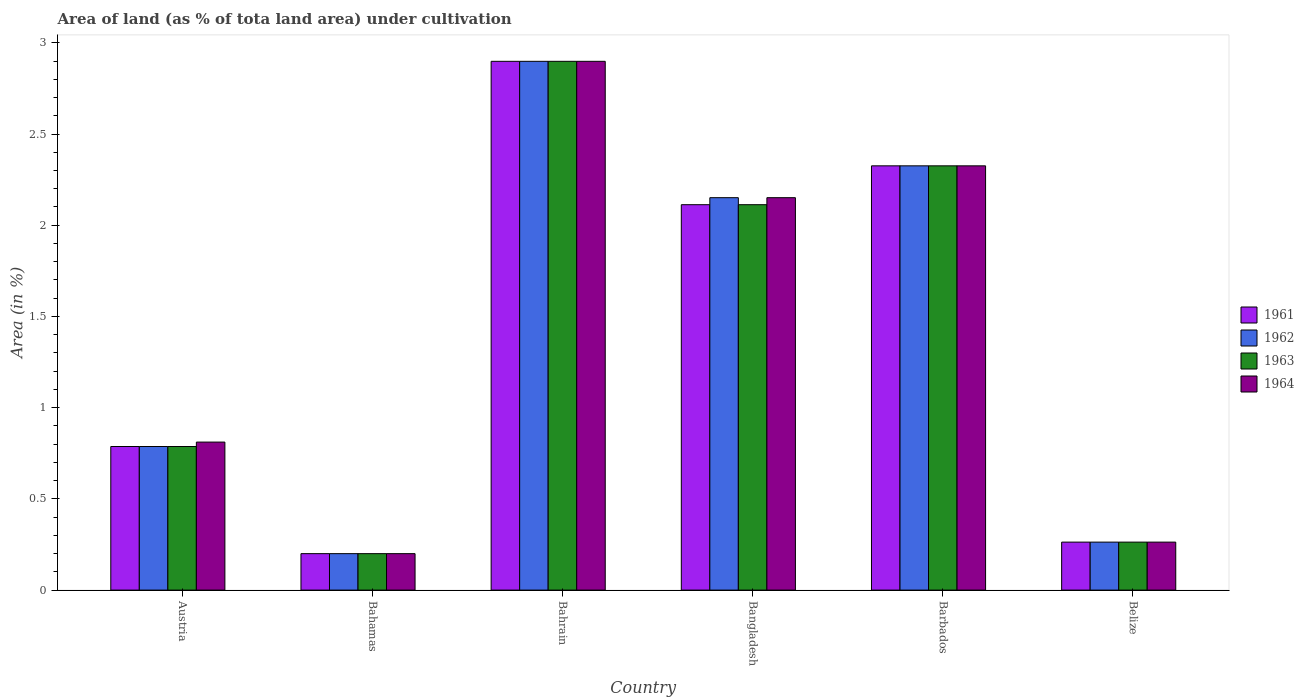How many different coloured bars are there?
Make the answer very short. 4. Are the number of bars on each tick of the X-axis equal?
Your answer should be very brief. Yes. How many bars are there on the 1st tick from the left?
Your answer should be compact. 4. What is the label of the 1st group of bars from the left?
Keep it short and to the point. Austria. What is the percentage of land under cultivation in 1964 in Bangladesh?
Your answer should be compact. 2.15. Across all countries, what is the maximum percentage of land under cultivation in 1964?
Your answer should be very brief. 2.9. Across all countries, what is the minimum percentage of land under cultivation in 1963?
Provide a succinct answer. 0.2. In which country was the percentage of land under cultivation in 1963 maximum?
Your answer should be compact. Bahrain. In which country was the percentage of land under cultivation in 1963 minimum?
Give a very brief answer. Bahamas. What is the total percentage of land under cultivation in 1962 in the graph?
Provide a short and direct response. 8.63. What is the difference between the percentage of land under cultivation in 1962 in Austria and that in Belize?
Provide a short and direct response. 0.52. What is the difference between the percentage of land under cultivation in 1962 in Austria and the percentage of land under cultivation in 1963 in Bahrain?
Your response must be concise. -2.11. What is the average percentage of land under cultivation in 1961 per country?
Provide a short and direct response. 1.43. What is the ratio of the percentage of land under cultivation in 1963 in Bangladesh to that in Barbados?
Your answer should be very brief. 0.91. Is the percentage of land under cultivation in 1962 in Barbados less than that in Belize?
Keep it short and to the point. No. Is the difference between the percentage of land under cultivation in 1961 in Barbados and Belize greater than the difference between the percentage of land under cultivation in 1963 in Barbados and Belize?
Keep it short and to the point. No. What is the difference between the highest and the second highest percentage of land under cultivation in 1961?
Provide a short and direct response. 0.57. What is the difference between the highest and the lowest percentage of land under cultivation in 1962?
Give a very brief answer. 2.7. In how many countries, is the percentage of land under cultivation in 1963 greater than the average percentage of land under cultivation in 1963 taken over all countries?
Ensure brevity in your answer.  3. Is the sum of the percentage of land under cultivation in 1964 in Austria and Bahrain greater than the maximum percentage of land under cultivation in 1963 across all countries?
Keep it short and to the point. Yes. Is it the case that in every country, the sum of the percentage of land under cultivation in 1962 and percentage of land under cultivation in 1964 is greater than the sum of percentage of land under cultivation in 1961 and percentage of land under cultivation in 1963?
Offer a very short reply. No. What does the 2nd bar from the left in Bangladesh represents?
Offer a terse response. 1962. What does the 2nd bar from the right in Bahamas represents?
Provide a succinct answer. 1963. Is it the case that in every country, the sum of the percentage of land under cultivation in 1963 and percentage of land under cultivation in 1962 is greater than the percentage of land under cultivation in 1964?
Provide a succinct answer. Yes. How many bars are there?
Offer a very short reply. 24. Are all the bars in the graph horizontal?
Your answer should be compact. No. How many countries are there in the graph?
Give a very brief answer. 6. Does the graph contain grids?
Offer a terse response. No. Where does the legend appear in the graph?
Make the answer very short. Center right. What is the title of the graph?
Your answer should be very brief. Area of land (as % of tota land area) under cultivation. What is the label or title of the Y-axis?
Your response must be concise. Area (in %). What is the Area (in %) of 1961 in Austria?
Keep it short and to the point. 0.79. What is the Area (in %) of 1962 in Austria?
Provide a short and direct response. 0.79. What is the Area (in %) of 1963 in Austria?
Ensure brevity in your answer.  0.79. What is the Area (in %) of 1964 in Austria?
Give a very brief answer. 0.81. What is the Area (in %) in 1961 in Bahamas?
Your answer should be very brief. 0.2. What is the Area (in %) of 1962 in Bahamas?
Make the answer very short. 0.2. What is the Area (in %) in 1963 in Bahamas?
Your answer should be compact. 0.2. What is the Area (in %) of 1964 in Bahamas?
Your answer should be very brief. 0.2. What is the Area (in %) in 1961 in Bahrain?
Provide a succinct answer. 2.9. What is the Area (in %) of 1962 in Bahrain?
Make the answer very short. 2.9. What is the Area (in %) in 1963 in Bahrain?
Your answer should be compact. 2.9. What is the Area (in %) in 1964 in Bahrain?
Provide a short and direct response. 2.9. What is the Area (in %) in 1961 in Bangladesh?
Offer a very short reply. 2.11. What is the Area (in %) of 1962 in Bangladesh?
Your answer should be compact. 2.15. What is the Area (in %) of 1963 in Bangladesh?
Provide a succinct answer. 2.11. What is the Area (in %) of 1964 in Bangladesh?
Provide a short and direct response. 2.15. What is the Area (in %) in 1961 in Barbados?
Provide a succinct answer. 2.33. What is the Area (in %) in 1962 in Barbados?
Make the answer very short. 2.33. What is the Area (in %) of 1963 in Barbados?
Your answer should be compact. 2.33. What is the Area (in %) in 1964 in Barbados?
Your answer should be very brief. 2.33. What is the Area (in %) of 1961 in Belize?
Offer a very short reply. 0.26. What is the Area (in %) of 1962 in Belize?
Provide a short and direct response. 0.26. What is the Area (in %) of 1963 in Belize?
Ensure brevity in your answer.  0.26. What is the Area (in %) in 1964 in Belize?
Your answer should be compact. 0.26. Across all countries, what is the maximum Area (in %) in 1961?
Keep it short and to the point. 2.9. Across all countries, what is the maximum Area (in %) of 1962?
Give a very brief answer. 2.9. Across all countries, what is the maximum Area (in %) in 1963?
Keep it short and to the point. 2.9. Across all countries, what is the maximum Area (in %) in 1964?
Make the answer very short. 2.9. Across all countries, what is the minimum Area (in %) in 1961?
Ensure brevity in your answer.  0.2. Across all countries, what is the minimum Area (in %) of 1962?
Your answer should be very brief. 0.2. Across all countries, what is the minimum Area (in %) of 1963?
Give a very brief answer. 0.2. Across all countries, what is the minimum Area (in %) of 1964?
Your answer should be compact. 0.2. What is the total Area (in %) in 1961 in the graph?
Provide a succinct answer. 8.59. What is the total Area (in %) of 1962 in the graph?
Your answer should be compact. 8.63. What is the total Area (in %) of 1963 in the graph?
Ensure brevity in your answer.  8.59. What is the total Area (in %) in 1964 in the graph?
Your answer should be compact. 8.65. What is the difference between the Area (in %) of 1961 in Austria and that in Bahamas?
Your response must be concise. 0.59. What is the difference between the Area (in %) in 1962 in Austria and that in Bahamas?
Offer a very short reply. 0.59. What is the difference between the Area (in %) in 1963 in Austria and that in Bahamas?
Your answer should be very brief. 0.59. What is the difference between the Area (in %) in 1964 in Austria and that in Bahamas?
Your answer should be compact. 0.61. What is the difference between the Area (in %) of 1961 in Austria and that in Bahrain?
Your answer should be compact. -2.11. What is the difference between the Area (in %) in 1962 in Austria and that in Bahrain?
Provide a succinct answer. -2.11. What is the difference between the Area (in %) of 1963 in Austria and that in Bahrain?
Make the answer very short. -2.11. What is the difference between the Area (in %) in 1964 in Austria and that in Bahrain?
Offer a terse response. -2.09. What is the difference between the Area (in %) of 1961 in Austria and that in Bangladesh?
Make the answer very short. -1.33. What is the difference between the Area (in %) in 1962 in Austria and that in Bangladesh?
Keep it short and to the point. -1.36. What is the difference between the Area (in %) of 1963 in Austria and that in Bangladesh?
Offer a very short reply. -1.33. What is the difference between the Area (in %) in 1964 in Austria and that in Bangladesh?
Offer a very short reply. -1.34. What is the difference between the Area (in %) of 1961 in Austria and that in Barbados?
Make the answer very short. -1.54. What is the difference between the Area (in %) of 1962 in Austria and that in Barbados?
Provide a succinct answer. -1.54. What is the difference between the Area (in %) in 1963 in Austria and that in Barbados?
Provide a short and direct response. -1.54. What is the difference between the Area (in %) in 1964 in Austria and that in Barbados?
Provide a short and direct response. -1.51. What is the difference between the Area (in %) of 1961 in Austria and that in Belize?
Your answer should be compact. 0.52. What is the difference between the Area (in %) of 1962 in Austria and that in Belize?
Make the answer very short. 0.52. What is the difference between the Area (in %) in 1963 in Austria and that in Belize?
Your response must be concise. 0.52. What is the difference between the Area (in %) of 1964 in Austria and that in Belize?
Your answer should be very brief. 0.55. What is the difference between the Area (in %) in 1961 in Bahamas and that in Bahrain?
Give a very brief answer. -2.7. What is the difference between the Area (in %) of 1962 in Bahamas and that in Bahrain?
Give a very brief answer. -2.7. What is the difference between the Area (in %) of 1963 in Bahamas and that in Bahrain?
Your answer should be very brief. -2.7. What is the difference between the Area (in %) of 1964 in Bahamas and that in Bahrain?
Your response must be concise. -2.7. What is the difference between the Area (in %) of 1961 in Bahamas and that in Bangladesh?
Your answer should be very brief. -1.91. What is the difference between the Area (in %) of 1962 in Bahamas and that in Bangladesh?
Offer a very short reply. -1.95. What is the difference between the Area (in %) of 1963 in Bahamas and that in Bangladesh?
Your answer should be very brief. -1.91. What is the difference between the Area (in %) in 1964 in Bahamas and that in Bangladesh?
Keep it short and to the point. -1.95. What is the difference between the Area (in %) in 1961 in Bahamas and that in Barbados?
Offer a very short reply. -2.13. What is the difference between the Area (in %) of 1962 in Bahamas and that in Barbados?
Provide a succinct answer. -2.13. What is the difference between the Area (in %) of 1963 in Bahamas and that in Barbados?
Make the answer very short. -2.13. What is the difference between the Area (in %) in 1964 in Bahamas and that in Barbados?
Ensure brevity in your answer.  -2.13. What is the difference between the Area (in %) of 1961 in Bahamas and that in Belize?
Give a very brief answer. -0.06. What is the difference between the Area (in %) in 1962 in Bahamas and that in Belize?
Provide a short and direct response. -0.06. What is the difference between the Area (in %) of 1963 in Bahamas and that in Belize?
Offer a very short reply. -0.06. What is the difference between the Area (in %) in 1964 in Bahamas and that in Belize?
Offer a terse response. -0.06. What is the difference between the Area (in %) in 1961 in Bahrain and that in Bangladesh?
Offer a very short reply. 0.79. What is the difference between the Area (in %) in 1962 in Bahrain and that in Bangladesh?
Offer a very short reply. 0.75. What is the difference between the Area (in %) in 1963 in Bahrain and that in Bangladesh?
Provide a short and direct response. 0.79. What is the difference between the Area (in %) of 1964 in Bahrain and that in Bangladesh?
Give a very brief answer. 0.75. What is the difference between the Area (in %) of 1961 in Bahrain and that in Barbados?
Give a very brief answer. 0.57. What is the difference between the Area (in %) in 1962 in Bahrain and that in Barbados?
Offer a very short reply. 0.57. What is the difference between the Area (in %) in 1963 in Bahrain and that in Barbados?
Ensure brevity in your answer.  0.57. What is the difference between the Area (in %) in 1964 in Bahrain and that in Barbados?
Provide a short and direct response. 0.57. What is the difference between the Area (in %) of 1961 in Bahrain and that in Belize?
Your response must be concise. 2.64. What is the difference between the Area (in %) of 1962 in Bahrain and that in Belize?
Offer a terse response. 2.64. What is the difference between the Area (in %) of 1963 in Bahrain and that in Belize?
Provide a succinct answer. 2.64. What is the difference between the Area (in %) in 1964 in Bahrain and that in Belize?
Provide a short and direct response. 2.64. What is the difference between the Area (in %) in 1961 in Bangladesh and that in Barbados?
Provide a succinct answer. -0.21. What is the difference between the Area (in %) in 1962 in Bangladesh and that in Barbados?
Your response must be concise. -0.17. What is the difference between the Area (in %) in 1963 in Bangladesh and that in Barbados?
Keep it short and to the point. -0.21. What is the difference between the Area (in %) in 1964 in Bangladesh and that in Barbados?
Make the answer very short. -0.17. What is the difference between the Area (in %) of 1961 in Bangladesh and that in Belize?
Your answer should be very brief. 1.85. What is the difference between the Area (in %) in 1962 in Bangladesh and that in Belize?
Make the answer very short. 1.89. What is the difference between the Area (in %) of 1963 in Bangladesh and that in Belize?
Provide a short and direct response. 1.85. What is the difference between the Area (in %) in 1964 in Bangladesh and that in Belize?
Provide a short and direct response. 1.89. What is the difference between the Area (in %) in 1961 in Barbados and that in Belize?
Provide a short and direct response. 2.06. What is the difference between the Area (in %) of 1962 in Barbados and that in Belize?
Your response must be concise. 2.06. What is the difference between the Area (in %) of 1963 in Barbados and that in Belize?
Keep it short and to the point. 2.06. What is the difference between the Area (in %) of 1964 in Barbados and that in Belize?
Offer a terse response. 2.06. What is the difference between the Area (in %) of 1961 in Austria and the Area (in %) of 1962 in Bahamas?
Make the answer very short. 0.59. What is the difference between the Area (in %) in 1961 in Austria and the Area (in %) in 1963 in Bahamas?
Make the answer very short. 0.59. What is the difference between the Area (in %) of 1961 in Austria and the Area (in %) of 1964 in Bahamas?
Offer a terse response. 0.59. What is the difference between the Area (in %) of 1962 in Austria and the Area (in %) of 1963 in Bahamas?
Give a very brief answer. 0.59. What is the difference between the Area (in %) in 1962 in Austria and the Area (in %) in 1964 in Bahamas?
Keep it short and to the point. 0.59. What is the difference between the Area (in %) in 1963 in Austria and the Area (in %) in 1964 in Bahamas?
Offer a terse response. 0.59. What is the difference between the Area (in %) of 1961 in Austria and the Area (in %) of 1962 in Bahrain?
Ensure brevity in your answer.  -2.11. What is the difference between the Area (in %) of 1961 in Austria and the Area (in %) of 1963 in Bahrain?
Keep it short and to the point. -2.11. What is the difference between the Area (in %) of 1961 in Austria and the Area (in %) of 1964 in Bahrain?
Make the answer very short. -2.11. What is the difference between the Area (in %) in 1962 in Austria and the Area (in %) in 1963 in Bahrain?
Provide a short and direct response. -2.11. What is the difference between the Area (in %) of 1962 in Austria and the Area (in %) of 1964 in Bahrain?
Your response must be concise. -2.11. What is the difference between the Area (in %) in 1963 in Austria and the Area (in %) in 1964 in Bahrain?
Offer a very short reply. -2.11. What is the difference between the Area (in %) in 1961 in Austria and the Area (in %) in 1962 in Bangladesh?
Make the answer very short. -1.36. What is the difference between the Area (in %) of 1961 in Austria and the Area (in %) of 1963 in Bangladesh?
Your answer should be very brief. -1.33. What is the difference between the Area (in %) of 1961 in Austria and the Area (in %) of 1964 in Bangladesh?
Your answer should be very brief. -1.36. What is the difference between the Area (in %) in 1962 in Austria and the Area (in %) in 1963 in Bangladesh?
Keep it short and to the point. -1.33. What is the difference between the Area (in %) of 1962 in Austria and the Area (in %) of 1964 in Bangladesh?
Offer a terse response. -1.36. What is the difference between the Area (in %) of 1963 in Austria and the Area (in %) of 1964 in Bangladesh?
Keep it short and to the point. -1.36. What is the difference between the Area (in %) in 1961 in Austria and the Area (in %) in 1962 in Barbados?
Offer a terse response. -1.54. What is the difference between the Area (in %) of 1961 in Austria and the Area (in %) of 1963 in Barbados?
Your answer should be compact. -1.54. What is the difference between the Area (in %) in 1961 in Austria and the Area (in %) in 1964 in Barbados?
Keep it short and to the point. -1.54. What is the difference between the Area (in %) in 1962 in Austria and the Area (in %) in 1963 in Barbados?
Offer a terse response. -1.54. What is the difference between the Area (in %) of 1962 in Austria and the Area (in %) of 1964 in Barbados?
Offer a very short reply. -1.54. What is the difference between the Area (in %) of 1963 in Austria and the Area (in %) of 1964 in Barbados?
Make the answer very short. -1.54. What is the difference between the Area (in %) of 1961 in Austria and the Area (in %) of 1962 in Belize?
Give a very brief answer. 0.52. What is the difference between the Area (in %) of 1961 in Austria and the Area (in %) of 1963 in Belize?
Provide a short and direct response. 0.52. What is the difference between the Area (in %) in 1961 in Austria and the Area (in %) in 1964 in Belize?
Offer a very short reply. 0.52. What is the difference between the Area (in %) in 1962 in Austria and the Area (in %) in 1963 in Belize?
Your answer should be very brief. 0.52. What is the difference between the Area (in %) of 1962 in Austria and the Area (in %) of 1964 in Belize?
Offer a terse response. 0.52. What is the difference between the Area (in %) in 1963 in Austria and the Area (in %) in 1964 in Belize?
Provide a short and direct response. 0.52. What is the difference between the Area (in %) of 1961 in Bahamas and the Area (in %) of 1962 in Bahrain?
Offer a very short reply. -2.7. What is the difference between the Area (in %) in 1961 in Bahamas and the Area (in %) in 1963 in Bahrain?
Your response must be concise. -2.7. What is the difference between the Area (in %) in 1961 in Bahamas and the Area (in %) in 1964 in Bahrain?
Provide a short and direct response. -2.7. What is the difference between the Area (in %) in 1962 in Bahamas and the Area (in %) in 1963 in Bahrain?
Give a very brief answer. -2.7. What is the difference between the Area (in %) in 1962 in Bahamas and the Area (in %) in 1964 in Bahrain?
Give a very brief answer. -2.7. What is the difference between the Area (in %) of 1963 in Bahamas and the Area (in %) of 1964 in Bahrain?
Make the answer very short. -2.7. What is the difference between the Area (in %) in 1961 in Bahamas and the Area (in %) in 1962 in Bangladesh?
Provide a succinct answer. -1.95. What is the difference between the Area (in %) of 1961 in Bahamas and the Area (in %) of 1963 in Bangladesh?
Give a very brief answer. -1.91. What is the difference between the Area (in %) in 1961 in Bahamas and the Area (in %) in 1964 in Bangladesh?
Make the answer very short. -1.95. What is the difference between the Area (in %) in 1962 in Bahamas and the Area (in %) in 1963 in Bangladesh?
Your response must be concise. -1.91. What is the difference between the Area (in %) in 1962 in Bahamas and the Area (in %) in 1964 in Bangladesh?
Provide a succinct answer. -1.95. What is the difference between the Area (in %) of 1963 in Bahamas and the Area (in %) of 1964 in Bangladesh?
Keep it short and to the point. -1.95. What is the difference between the Area (in %) in 1961 in Bahamas and the Area (in %) in 1962 in Barbados?
Your response must be concise. -2.13. What is the difference between the Area (in %) in 1961 in Bahamas and the Area (in %) in 1963 in Barbados?
Offer a terse response. -2.13. What is the difference between the Area (in %) in 1961 in Bahamas and the Area (in %) in 1964 in Barbados?
Your response must be concise. -2.13. What is the difference between the Area (in %) of 1962 in Bahamas and the Area (in %) of 1963 in Barbados?
Give a very brief answer. -2.13. What is the difference between the Area (in %) in 1962 in Bahamas and the Area (in %) in 1964 in Barbados?
Offer a terse response. -2.13. What is the difference between the Area (in %) in 1963 in Bahamas and the Area (in %) in 1964 in Barbados?
Your answer should be compact. -2.13. What is the difference between the Area (in %) in 1961 in Bahamas and the Area (in %) in 1962 in Belize?
Provide a short and direct response. -0.06. What is the difference between the Area (in %) of 1961 in Bahamas and the Area (in %) of 1963 in Belize?
Ensure brevity in your answer.  -0.06. What is the difference between the Area (in %) of 1961 in Bahamas and the Area (in %) of 1964 in Belize?
Your answer should be very brief. -0.06. What is the difference between the Area (in %) in 1962 in Bahamas and the Area (in %) in 1963 in Belize?
Make the answer very short. -0.06. What is the difference between the Area (in %) of 1962 in Bahamas and the Area (in %) of 1964 in Belize?
Your answer should be very brief. -0.06. What is the difference between the Area (in %) of 1963 in Bahamas and the Area (in %) of 1964 in Belize?
Provide a short and direct response. -0.06. What is the difference between the Area (in %) in 1961 in Bahrain and the Area (in %) in 1962 in Bangladesh?
Offer a terse response. 0.75. What is the difference between the Area (in %) in 1961 in Bahrain and the Area (in %) in 1963 in Bangladesh?
Your response must be concise. 0.79. What is the difference between the Area (in %) in 1961 in Bahrain and the Area (in %) in 1964 in Bangladesh?
Make the answer very short. 0.75. What is the difference between the Area (in %) of 1962 in Bahrain and the Area (in %) of 1963 in Bangladesh?
Your response must be concise. 0.79. What is the difference between the Area (in %) in 1962 in Bahrain and the Area (in %) in 1964 in Bangladesh?
Offer a terse response. 0.75. What is the difference between the Area (in %) in 1963 in Bahrain and the Area (in %) in 1964 in Bangladesh?
Ensure brevity in your answer.  0.75. What is the difference between the Area (in %) in 1961 in Bahrain and the Area (in %) in 1962 in Barbados?
Keep it short and to the point. 0.57. What is the difference between the Area (in %) in 1961 in Bahrain and the Area (in %) in 1963 in Barbados?
Your answer should be compact. 0.57. What is the difference between the Area (in %) of 1961 in Bahrain and the Area (in %) of 1964 in Barbados?
Your response must be concise. 0.57. What is the difference between the Area (in %) in 1962 in Bahrain and the Area (in %) in 1963 in Barbados?
Provide a succinct answer. 0.57. What is the difference between the Area (in %) in 1962 in Bahrain and the Area (in %) in 1964 in Barbados?
Keep it short and to the point. 0.57. What is the difference between the Area (in %) of 1963 in Bahrain and the Area (in %) of 1964 in Barbados?
Provide a short and direct response. 0.57. What is the difference between the Area (in %) in 1961 in Bahrain and the Area (in %) in 1962 in Belize?
Provide a succinct answer. 2.64. What is the difference between the Area (in %) of 1961 in Bahrain and the Area (in %) of 1963 in Belize?
Provide a short and direct response. 2.64. What is the difference between the Area (in %) in 1961 in Bahrain and the Area (in %) in 1964 in Belize?
Provide a succinct answer. 2.64. What is the difference between the Area (in %) in 1962 in Bahrain and the Area (in %) in 1963 in Belize?
Keep it short and to the point. 2.64. What is the difference between the Area (in %) in 1962 in Bahrain and the Area (in %) in 1964 in Belize?
Make the answer very short. 2.64. What is the difference between the Area (in %) of 1963 in Bahrain and the Area (in %) of 1964 in Belize?
Offer a very short reply. 2.64. What is the difference between the Area (in %) in 1961 in Bangladesh and the Area (in %) in 1962 in Barbados?
Offer a very short reply. -0.21. What is the difference between the Area (in %) in 1961 in Bangladesh and the Area (in %) in 1963 in Barbados?
Offer a terse response. -0.21. What is the difference between the Area (in %) of 1961 in Bangladesh and the Area (in %) of 1964 in Barbados?
Ensure brevity in your answer.  -0.21. What is the difference between the Area (in %) in 1962 in Bangladesh and the Area (in %) in 1963 in Barbados?
Provide a short and direct response. -0.17. What is the difference between the Area (in %) of 1962 in Bangladesh and the Area (in %) of 1964 in Barbados?
Make the answer very short. -0.17. What is the difference between the Area (in %) of 1963 in Bangladesh and the Area (in %) of 1964 in Barbados?
Your answer should be very brief. -0.21. What is the difference between the Area (in %) in 1961 in Bangladesh and the Area (in %) in 1962 in Belize?
Provide a succinct answer. 1.85. What is the difference between the Area (in %) of 1961 in Bangladesh and the Area (in %) of 1963 in Belize?
Your answer should be very brief. 1.85. What is the difference between the Area (in %) of 1961 in Bangladesh and the Area (in %) of 1964 in Belize?
Provide a short and direct response. 1.85. What is the difference between the Area (in %) in 1962 in Bangladesh and the Area (in %) in 1963 in Belize?
Give a very brief answer. 1.89. What is the difference between the Area (in %) of 1962 in Bangladesh and the Area (in %) of 1964 in Belize?
Keep it short and to the point. 1.89. What is the difference between the Area (in %) in 1963 in Bangladesh and the Area (in %) in 1964 in Belize?
Keep it short and to the point. 1.85. What is the difference between the Area (in %) in 1961 in Barbados and the Area (in %) in 1962 in Belize?
Keep it short and to the point. 2.06. What is the difference between the Area (in %) of 1961 in Barbados and the Area (in %) of 1963 in Belize?
Your answer should be compact. 2.06. What is the difference between the Area (in %) in 1961 in Barbados and the Area (in %) in 1964 in Belize?
Your response must be concise. 2.06. What is the difference between the Area (in %) in 1962 in Barbados and the Area (in %) in 1963 in Belize?
Your answer should be very brief. 2.06. What is the difference between the Area (in %) of 1962 in Barbados and the Area (in %) of 1964 in Belize?
Ensure brevity in your answer.  2.06. What is the difference between the Area (in %) in 1963 in Barbados and the Area (in %) in 1964 in Belize?
Keep it short and to the point. 2.06. What is the average Area (in %) in 1961 per country?
Offer a terse response. 1.43. What is the average Area (in %) in 1962 per country?
Your response must be concise. 1.44. What is the average Area (in %) in 1963 per country?
Provide a succinct answer. 1.43. What is the average Area (in %) of 1964 per country?
Provide a succinct answer. 1.44. What is the difference between the Area (in %) in 1961 and Area (in %) in 1962 in Austria?
Your answer should be compact. 0. What is the difference between the Area (in %) of 1961 and Area (in %) of 1964 in Austria?
Offer a terse response. -0.02. What is the difference between the Area (in %) of 1962 and Area (in %) of 1963 in Austria?
Provide a short and direct response. 0. What is the difference between the Area (in %) of 1962 and Area (in %) of 1964 in Austria?
Your answer should be very brief. -0.02. What is the difference between the Area (in %) of 1963 and Area (in %) of 1964 in Austria?
Ensure brevity in your answer.  -0.02. What is the difference between the Area (in %) of 1961 and Area (in %) of 1963 in Bahamas?
Your response must be concise. 0. What is the difference between the Area (in %) of 1961 and Area (in %) of 1964 in Bahamas?
Give a very brief answer. 0. What is the difference between the Area (in %) of 1962 and Area (in %) of 1964 in Bahamas?
Provide a short and direct response. 0. What is the difference between the Area (in %) in 1963 and Area (in %) in 1964 in Bahamas?
Your answer should be very brief. 0. What is the difference between the Area (in %) of 1961 and Area (in %) of 1962 in Bahrain?
Provide a short and direct response. 0. What is the difference between the Area (in %) of 1961 and Area (in %) of 1962 in Bangladesh?
Provide a short and direct response. -0.04. What is the difference between the Area (in %) of 1961 and Area (in %) of 1963 in Bangladesh?
Keep it short and to the point. 0. What is the difference between the Area (in %) in 1961 and Area (in %) in 1964 in Bangladesh?
Give a very brief answer. -0.04. What is the difference between the Area (in %) in 1962 and Area (in %) in 1963 in Bangladesh?
Your answer should be compact. 0.04. What is the difference between the Area (in %) in 1963 and Area (in %) in 1964 in Bangladesh?
Offer a very short reply. -0.04. What is the difference between the Area (in %) of 1961 and Area (in %) of 1963 in Barbados?
Your answer should be compact. 0. What is the difference between the Area (in %) of 1962 and Area (in %) of 1963 in Barbados?
Offer a very short reply. 0. What is the difference between the Area (in %) in 1961 and Area (in %) in 1962 in Belize?
Ensure brevity in your answer.  0. What is the difference between the Area (in %) of 1961 and Area (in %) of 1963 in Belize?
Provide a succinct answer. 0. What is the difference between the Area (in %) of 1961 and Area (in %) of 1964 in Belize?
Make the answer very short. 0. What is the difference between the Area (in %) in 1962 and Area (in %) in 1964 in Belize?
Your answer should be compact. 0. What is the difference between the Area (in %) in 1963 and Area (in %) in 1964 in Belize?
Your answer should be compact. 0. What is the ratio of the Area (in %) in 1961 in Austria to that in Bahamas?
Give a very brief answer. 3.94. What is the ratio of the Area (in %) in 1962 in Austria to that in Bahamas?
Your answer should be very brief. 3.94. What is the ratio of the Area (in %) of 1963 in Austria to that in Bahamas?
Provide a short and direct response. 3.94. What is the ratio of the Area (in %) of 1964 in Austria to that in Bahamas?
Offer a very short reply. 4.06. What is the ratio of the Area (in %) in 1961 in Austria to that in Bahrain?
Give a very brief answer. 0.27. What is the ratio of the Area (in %) of 1962 in Austria to that in Bahrain?
Your answer should be very brief. 0.27. What is the ratio of the Area (in %) of 1963 in Austria to that in Bahrain?
Offer a terse response. 0.27. What is the ratio of the Area (in %) of 1964 in Austria to that in Bahrain?
Keep it short and to the point. 0.28. What is the ratio of the Area (in %) in 1961 in Austria to that in Bangladesh?
Provide a succinct answer. 0.37. What is the ratio of the Area (in %) in 1962 in Austria to that in Bangladesh?
Your response must be concise. 0.37. What is the ratio of the Area (in %) in 1963 in Austria to that in Bangladesh?
Ensure brevity in your answer.  0.37. What is the ratio of the Area (in %) of 1964 in Austria to that in Bangladesh?
Provide a short and direct response. 0.38. What is the ratio of the Area (in %) in 1961 in Austria to that in Barbados?
Offer a terse response. 0.34. What is the ratio of the Area (in %) of 1962 in Austria to that in Barbados?
Keep it short and to the point. 0.34. What is the ratio of the Area (in %) of 1963 in Austria to that in Barbados?
Ensure brevity in your answer.  0.34. What is the ratio of the Area (in %) in 1964 in Austria to that in Barbados?
Keep it short and to the point. 0.35. What is the ratio of the Area (in %) in 1961 in Austria to that in Belize?
Your answer should be compact. 2.99. What is the ratio of the Area (in %) in 1962 in Austria to that in Belize?
Offer a terse response. 2.99. What is the ratio of the Area (in %) in 1963 in Austria to that in Belize?
Offer a very short reply. 2.99. What is the ratio of the Area (in %) of 1964 in Austria to that in Belize?
Your answer should be compact. 3.08. What is the ratio of the Area (in %) in 1961 in Bahamas to that in Bahrain?
Make the answer very short. 0.07. What is the ratio of the Area (in %) of 1962 in Bahamas to that in Bahrain?
Give a very brief answer. 0.07. What is the ratio of the Area (in %) in 1963 in Bahamas to that in Bahrain?
Your answer should be compact. 0.07. What is the ratio of the Area (in %) in 1964 in Bahamas to that in Bahrain?
Ensure brevity in your answer.  0.07. What is the ratio of the Area (in %) of 1961 in Bahamas to that in Bangladesh?
Offer a very short reply. 0.09. What is the ratio of the Area (in %) of 1962 in Bahamas to that in Bangladesh?
Provide a succinct answer. 0.09. What is the ratio of the Area (in %) in 1963 in Bahamas to that in Bangladesh?
Keep it short and to the point. 0.09. What is the ratio of the Area (in %) of 1964 in Bahamas to that in Bangladesh?
Your response must be concise. 0.09. What is the ratio of the Area (in %) in 1961 in Bahamas to that in Barbados?
Ensure brevity in your answer.  0.09. What is the ratio of the Area (in %) of 1962 in Bahamas to that in Barbados?
Offer a very short reply. 0.09. What is the ratio of the Area (in %) of 1963 in Bahamas to that in Barbados?
Provide a succinct answer. 0.09. What is the ratio of the Area (in %) in 1964 in Bahamas to that in Barbados?
Offer a terse response. 0.09. What is the ratio of the Area (in %) in 1961 in Bahamas to that in Belize?
Give a very brief answer. 0.76. What is the ratio of the Area (in %) in 1962 in Bahamas to that in Belize?
Make the answer very short. 0.76. What is the ratio of the Area (in %) in 1963 in Bahamas to that in Belize?
Ensure brevity in your answer.  0.76. What is the ratio of the Area (in %) in 1964 in Bahamas to that in Belize?
Make the answer very short. 0.76. What is the ratio of the Area (in %) of 1961 in Bahrain to that in Bangladesh?
Offer a very short reply. 1.37. What is the ratio of the Area (in %) of 1962 in Bahrain to that in Bangladesh?
Your answer should be compact. 1.35. What is the ratio of the Area (in %) in 1963 in Bahrain to that in Bangladesh?
Give a very brief answer. 1.37. What is the ratio of the Area (in %) of 1964 in Bahrain to that in Bangladesh?
Your response must be concise. 1.35. What is the ratio of the Area (in %) of 1961 in Bahrain to that in Barbados?
Ensure brevity in your answer.  1.25. What is the ratio of the Area (in %) in 1962 in Bahrain to that in Barbados?
Offer a very short reply. 1.25. What is the ratio of the Area (in %) of 1963 in Bahrain to that in Barbados?
Offer a terse response. 1.25. What is the ratio of the Area (in %) of 1964 in Bahrain to that in Barbados?
Make the answer very short. 1.25. What is the ratio of the Area (in %) of 1961 in Bahrain to that in Belize?
Give a very brief answer. 11.02. What is the ratio of the Area (in %) in 1962 in Bahrain to that in Belize?
Offer a very short reply. 11.02. What is the ratio of the Area (in %) in 1963 in Bahrain to that in Belize?
Give a very brief answer. 11.02. What is the ratio of the Area (in %) in 1964 in Bahrain to that in Belize?
Keep it short and to the point. 11.02. What is the ratio of the Area (in %) in 1961 in Bangladesh to that in Barbados?
Provide a succinct answer. 0.91. What is the ratio of the Area (in %) in 1962 in Bangladesh to that in Barbados?
Provide a short and direct response. 0.92. What is the ratio of the Area (in %) in 1963 in Bangladesh to that in Barbados?
Your answer should be very brief. 0.91. What is the ratio of the Area (in %) of 1964 in Bangladesh to that in Barbados?
Ensure brevity in your answer.  0.92. What is the ratio of the Area (in %) of 1961 in Bangladesh to that in Belize?
Keep it short and to the point. 8.03. What is the ratio of the Area (in %) of 1962 in Bangladesh to that in Belize?
Provide a succinct answer. 8.18. What is the ratio of the Area (in %) of 1963 in Bangladesh to that in Belize?
Provide a succinct answer. 8.03. What is the ratio of the Area (in %) in 1964 in Bangladesh to that in Belize?
Keep it short and to the point. 8.18. What is the ratio of the Area (in %) in 1961 in Barbados to that in Belize?
Offer a very short reply. 8.84. What is the ratio of the Area (in %) of 1962 in Barbados to that in Belize?
Provide a succinct answer. 8.84. What is the ratio of the Area (in %) in 1963 in Barbados to that in Belize?
Your answer should be very brief. 8.84. What is the ratio of the Area (in %) in 1964 in Barbados to that in Belize?
Ensure brevity in your answer.  8.84. What is the difference between the highest and the second highest Area (in %) in 1961?
Ensure brevity in your answer.  0.57. What is the difference between the highest and the second highest Area (in %) in 1962?
Provide a short and direct response. 0.57. What is the difference between the highest and the second highest Area (in %) in 1963?
Give a very brief answer. 0.57. What is the difference between the highest and the second highest Area (in %) of 1964?
Your response must be concise. 0.57. What is the difference between the highest and the lowest Area (in %) of 1961?
Your answer should be compact. 2.7. What is the difference between the highest and the lowest Area (in %) in 1962?
Your response must be concise. 2.7. What is the difference between the highest and the lowest Area (in %) of 1963?
Your answer should be very brief. 2.7. What is the difference between the highest and the lowest Area (in %) of 1964?
Give a very brief answer. 2.7. 